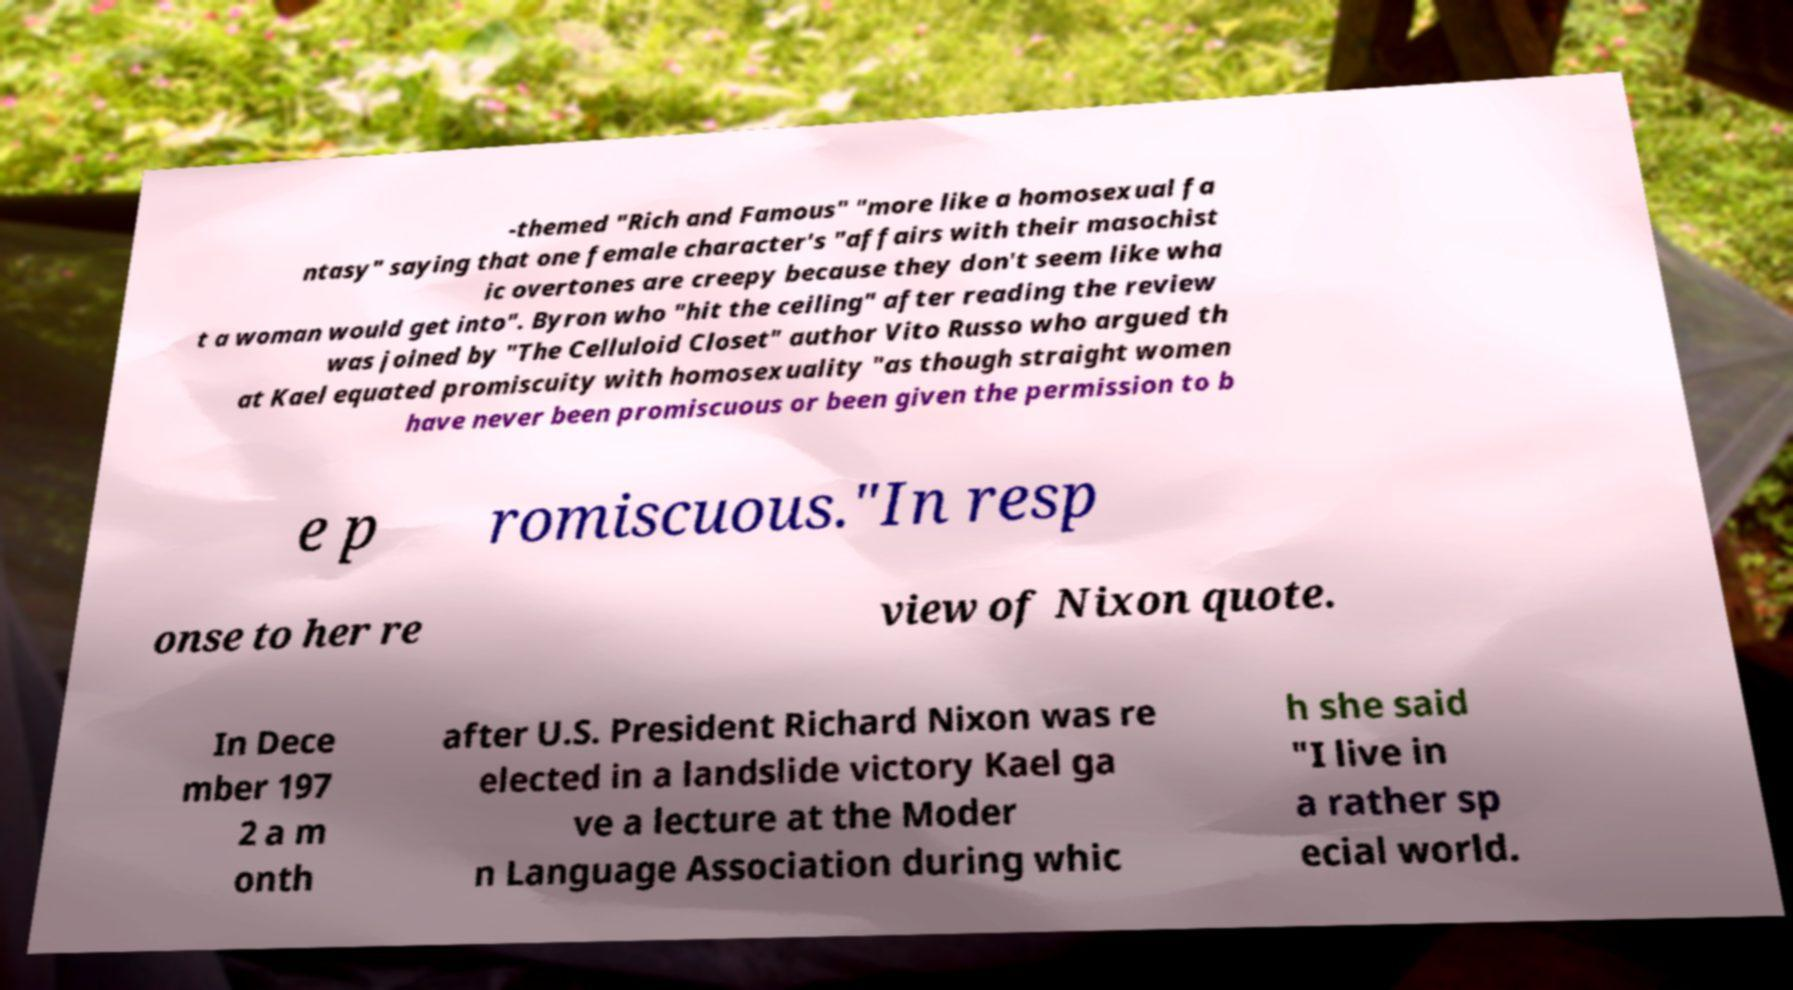Can you accurately transcribe the text from the provided image for me? -themed "Rich and Famous" "more like a homosexual fa ntasy" saying that one female character's "affairs with their masochist ic overtones are creepy because they don't seem like wha t a woman would get into". Byron who "hit the ceiling" after reading the review was joined by "The Celluloid Closet" author Vito Russo who argued th at Kael equated promiscuity with homosexuality "as though straight women have never been promiscuous or been given the permission to b e p romiscuous."In resp onse to her re view of Nixon quote. In Dece mber 197 2 a m onth after U.S. President Richard Nixon was re elected in a landslide victory Kael ga ve a lecture at the Moder n Language Association during whic h she said "I live in a rather sp ecial world. 